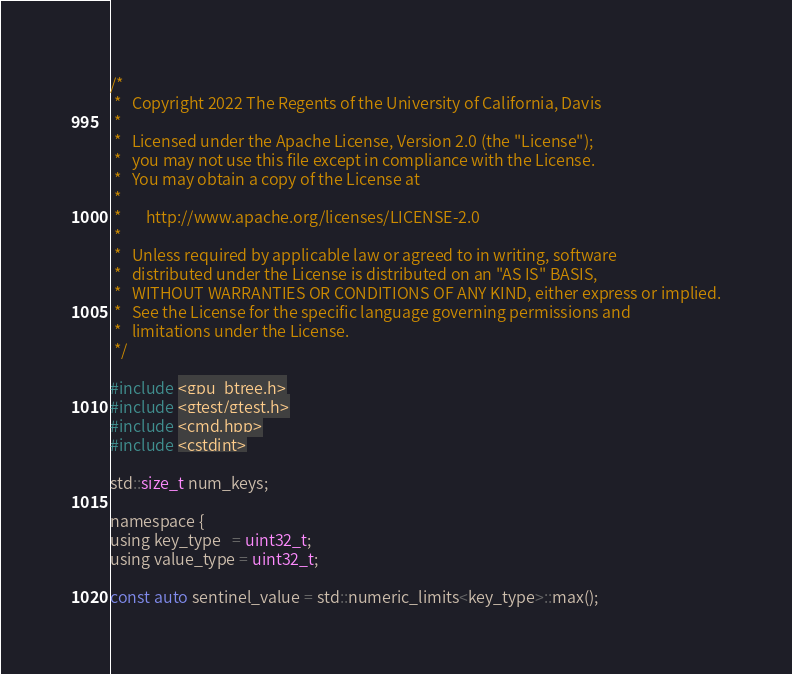<code> <loc_0><loc_0><loc_500><loc_500><_Cuda_>
/*
 *   Copyright 2022 The Regents of the University of California, Davis
 *
 *   Licensed under the Apache License, Version 2.0 (the "License");
 *   you may not use this file except in compliance with the License.
 *   You may obtain a copy of the License at
 *
 *       http://www.apache.org/licenses/LICENSE-2.0
 *
 *   Unless required by applicable law or agreed to in writing, software
 *   distributed under the License is distributed on an "AS IS" BASIS,
 *   WITHOUT WARRANTIES OR CONDITIONS OF ANY KIND, either express or implied.
 *   See the License for the specific language governing permissions and
 *   limitations under the License.
 */

#include <gpu_btree.h>
#include <gtest/gtest.h>
#include <cmd.hpp>
#include <cstdint>

std::size_t num_keys;

namespace {
using key_type   = uint32_t;
using value_type = uint32_t;

const auto sentinel_value = std::numeric_limits<key_type>::max();</code> 